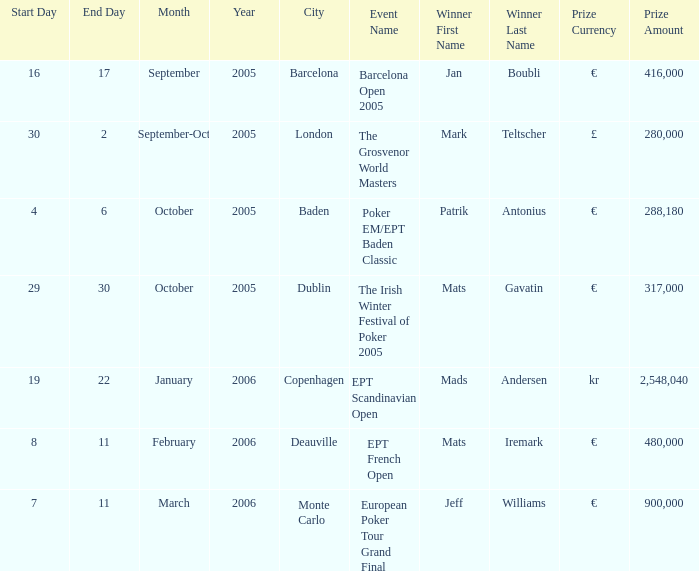What city did an event have a prize of €288,180? Baden. 